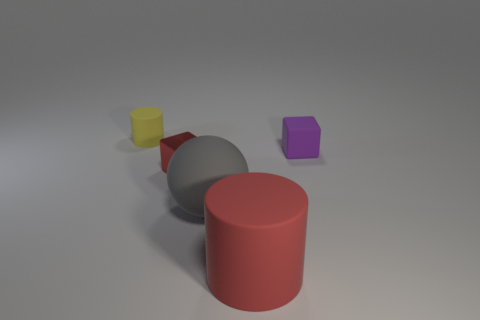Add 2 brown rubber things. How many objects exist? 7 Subtract all cylinders. How many objects are left? 3 Subtract all big purple matte spheres. Subtract all small cylinders. How many objects are left? 4 Add 3 small yellow matte objects. How many small yellow matte objects are left? 4 Add 4 gray matte spheres. How many gray matte spheres exist? 5 Subtract 0 cyan cylinders. How many objects are left? 5 